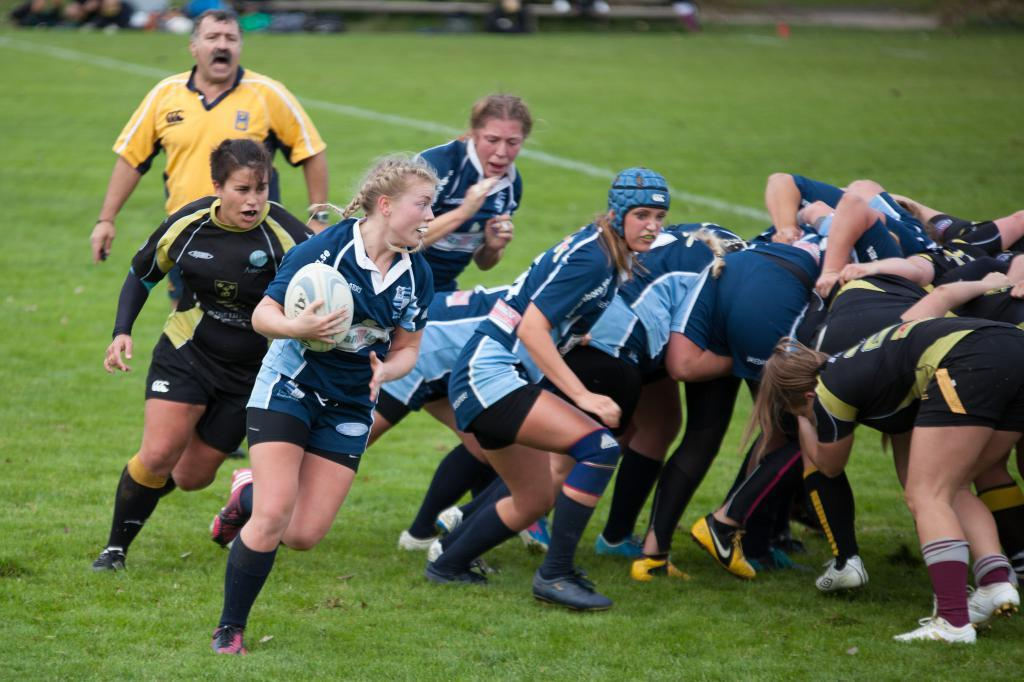What is happening in the image involving a group of people? The group of people are playing a game in the image. Where is the game being played? The game is being played on a ground. Can you describe the woman on the left side of the image? The woman on the left side of the image is holding a ball. What type of pan is being used by the woman in the image? There is no pan present in the image; the woman is holding a ball. Can you tell me where the clock is located in the image? There is no clock visible in the image. 